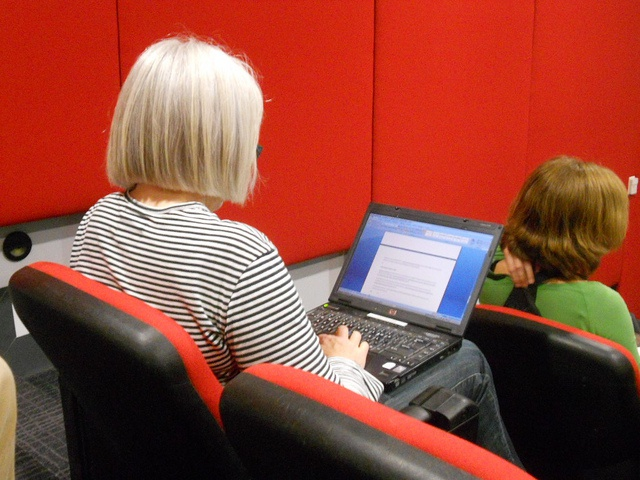Describe the objects in this image and their specific colors. I can see people in brown, white, gray, darkgray, and tan tones, chair in brown, black, salmon, gray, and maroon tones, chair in brown, black, gray, red, and maroon tones, laptop in brown, gray, lavender, darkgray, and black tones, and chair in brown, black, salmon, gray, and red tones in this image. 